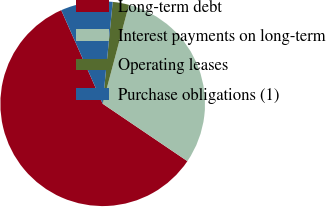<chart> <loc_0><loc_0><loc_500><loc_500><pie_chart><fcel>Long-term debt<fcel>Interest payments on long-term<fcel>Operating leases<fcel>Purchase obligations (1)<nl><fcel>58.88%<fcel>30.35%<fcel>2.57%<fcel>8.2%<nl></chart> 